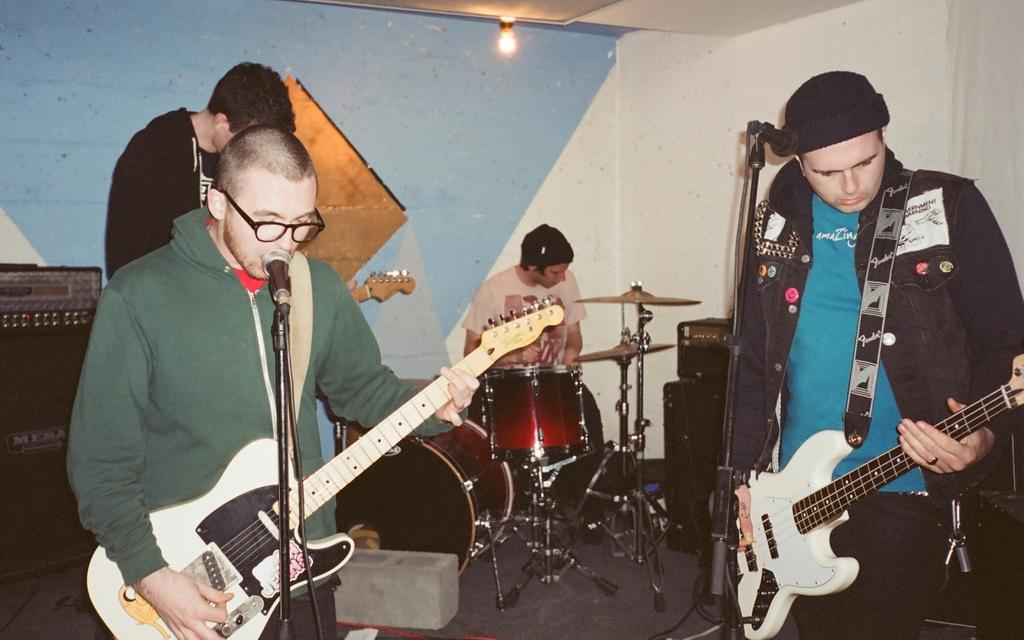How many people are present in the image? There are four people in the image. What are three of the people holding? Three of the people are holding guitars. What is the fourth person doing in the image? The fourth person is sitting next to a drum set. What can be seen in the background of the image? There is a light and a speaker in the background of the image. What type of steel is being used to construct the drum set in the image? There is no information about the type of steel used in the drum set, and the drum set is not the focus of the image. 